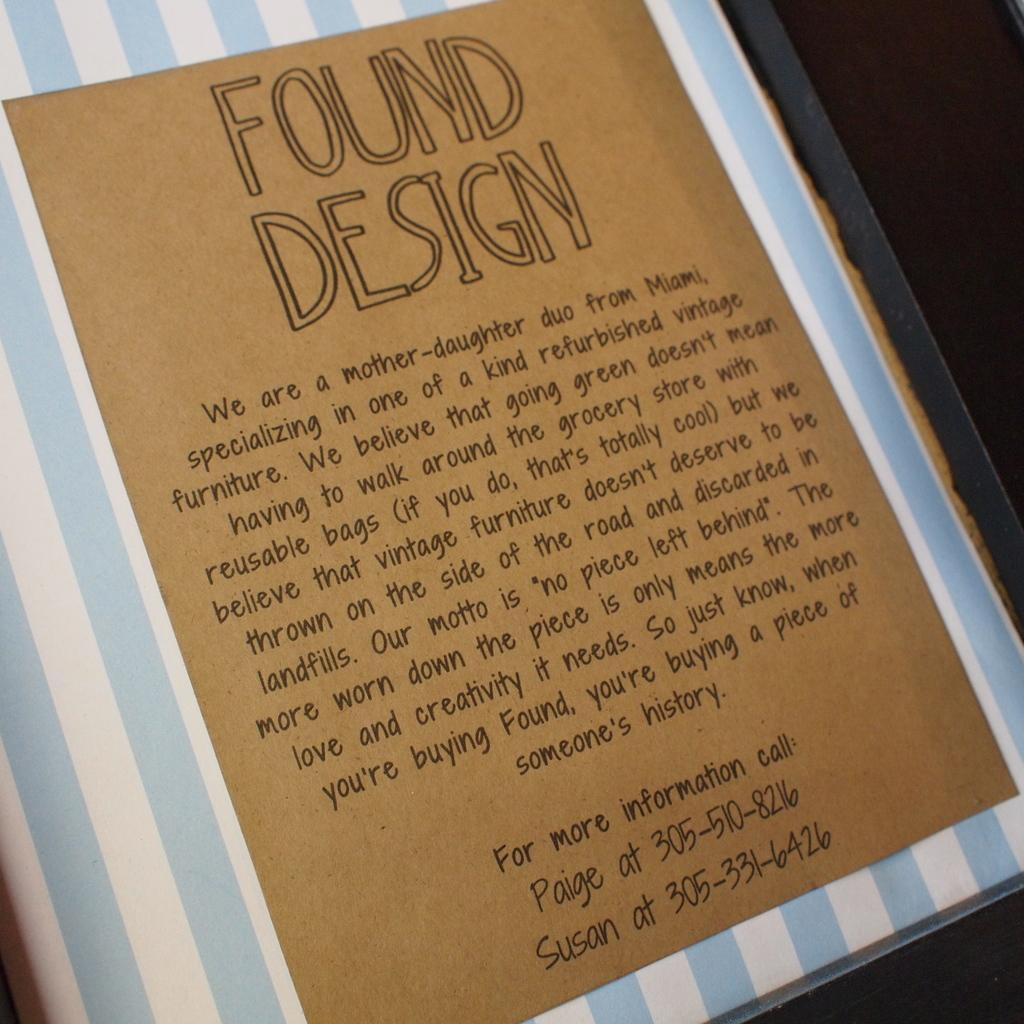Provide a one-sentence caption for the provided image. An advertisement for Found Design, which specializes in refurbished vintage furniture, is shown. 